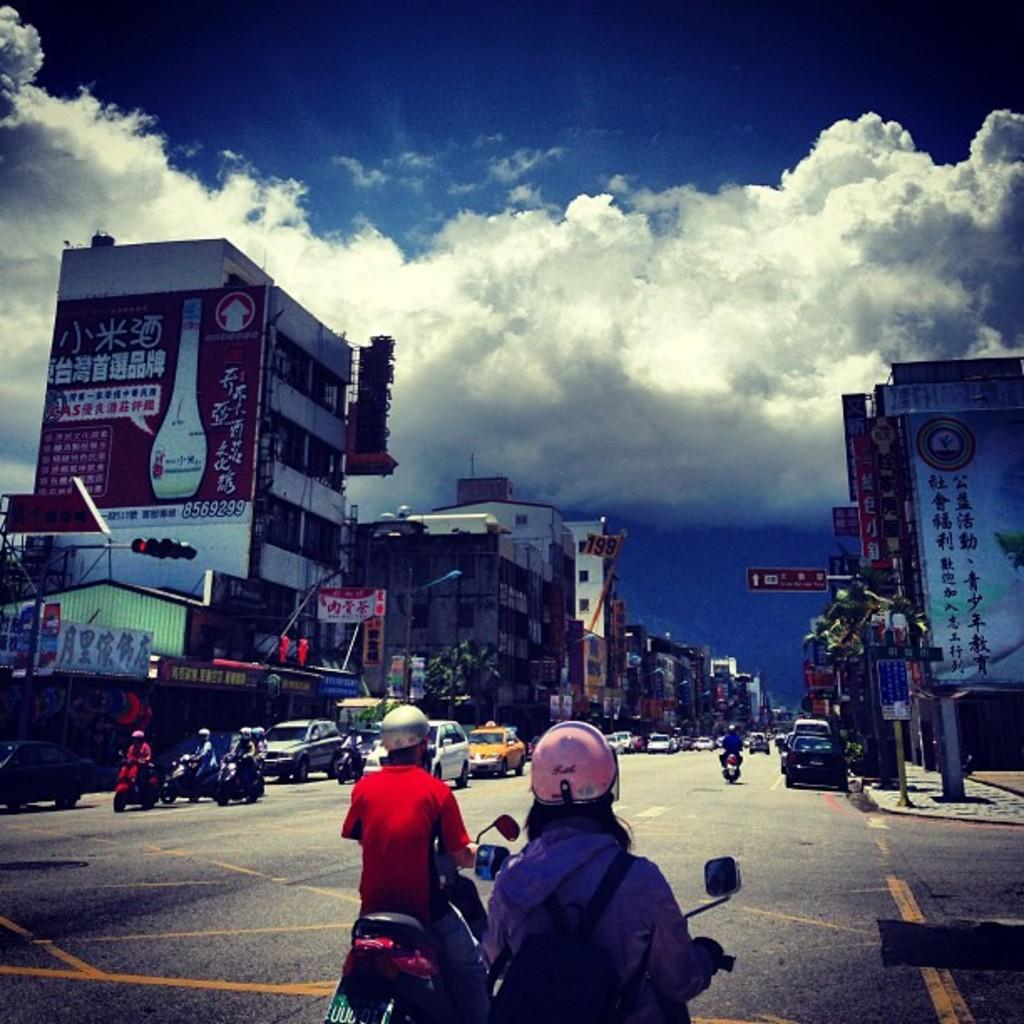What is happening in the image involving people and vehicles? There are people on vehicles in the image. What can be seen on the right side of the image? There is a building on the right side of the image. What is present on the left side of the image? There is a hoarding with text on the left side of the image. What is visible in the background of the image? The sky is visible in the background of the image. What can be observed about the sky in the image? There are clouds in the sky. Can you tell me how many frogs are sitting on the governor's patch in the image? There is no governor, frog, or patch present in the image. 